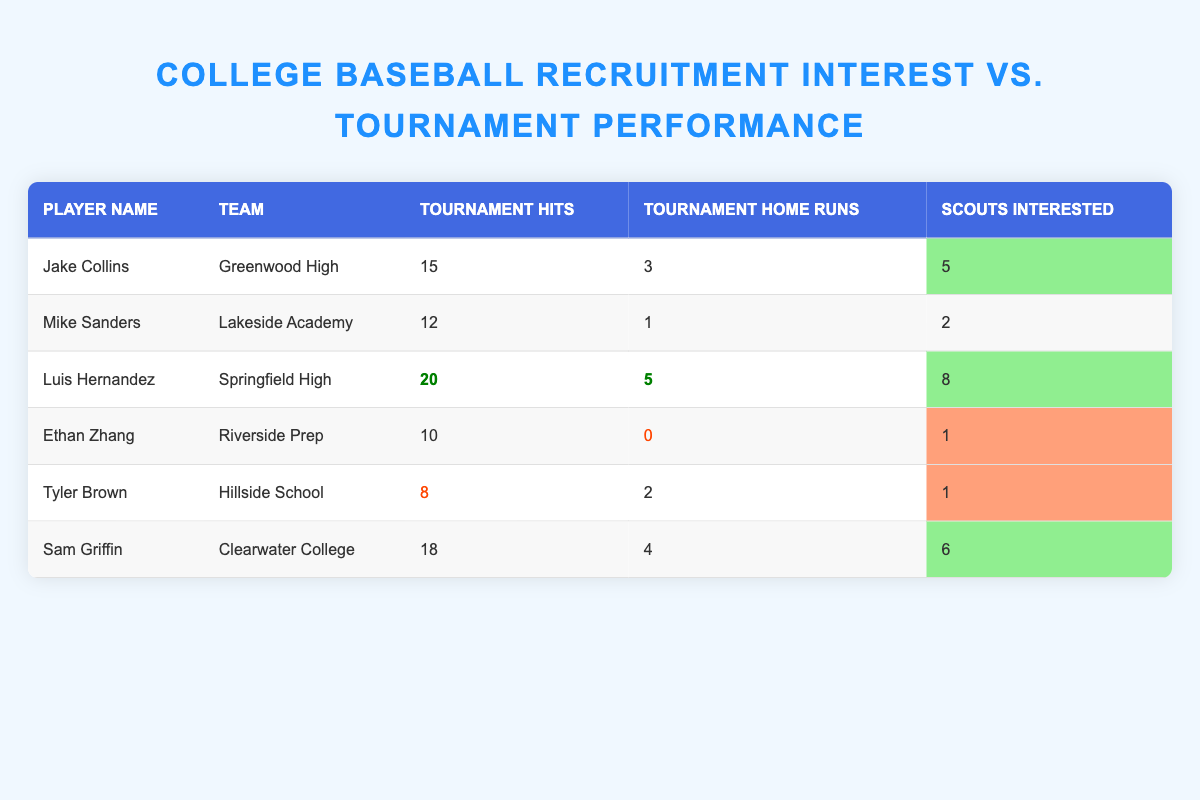What is the maximum number of scouts interested in a player? The maximum value in the "Scouts Interested" column is 8, which corresponds to the player Luis Hernandez.
Answer: 8 Which player had the highest number of tournament hits? By examining the "Tournament Hits" column, Luis Hernandez has the highest count at 20.
Answer: Luis Hernandez What is the average number of tournament home runs across all players? To find the average, sum the home runs (3 + 1 + 5 + 0 + 2 + 4 = 15) and divide by the number of players (6). The average is 15 / 6 = 2.5.
Answer: 2.5 Did any player with less than 10 tournament hits receive interest from scouts? Ethan Zhang and Tyler Brown both had less than 10 hits (10 and 8 respectively), and they received interest from scouts (1 in both cases). This confirms it's true.
Answer: Yes Which teams had players that scouted at least 5 times? The players from Greenwood High (5 scouts), Springfield High (8 scouts), and Clearwater College (6 scouts) had 5 or more scouts interested, so three teams qualify.
Answer: Greenwood High, Springfield High, Clearwater College What is the total number of tournament hits for players with more than 3 scouts? The eligible players are Luis Hernandez (20 hits), Sam Griffin (18 hits), and Jake Collins (15 hits). Summing these values gives 20 + 18 + 15 = 53.
Answer: 53 Is there a player who did not receive any scouts' interest despite performing well in terms of hits? When looking for a player with a high number of hits and low scouts interest, we see that even though Ethan Zhang had 10 hits, he only got 1 scout’s interest, confirming that this is true.
Answer: Yes Who had the least number of home runs and how many were recorded? Tyler Brown had the least number of home runs with a total of 2.
Answer: Tyler Brown, 2 